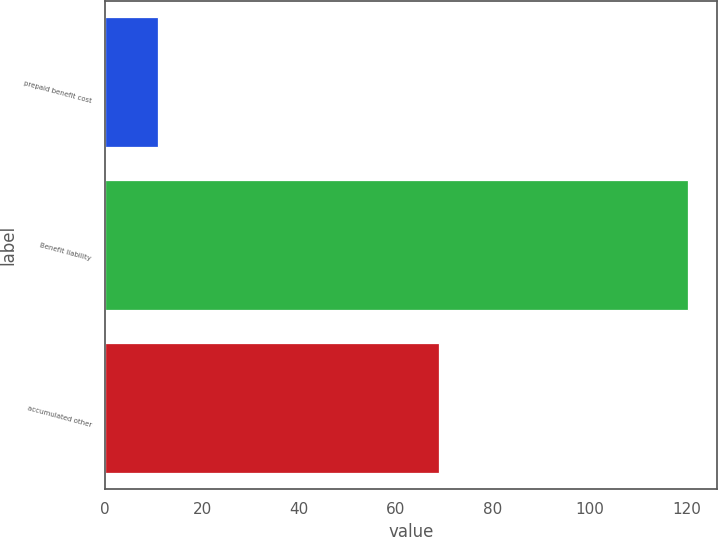<chart> <loc_0><loc_0><loc_500><loc_500><bar_chart><fcel>prepaid benefit cost<fcel>Benefit liability<fcel>accumulated other<nl><fcel>10.9<fcel>120.2<fcel>68.9<nl></chart> 